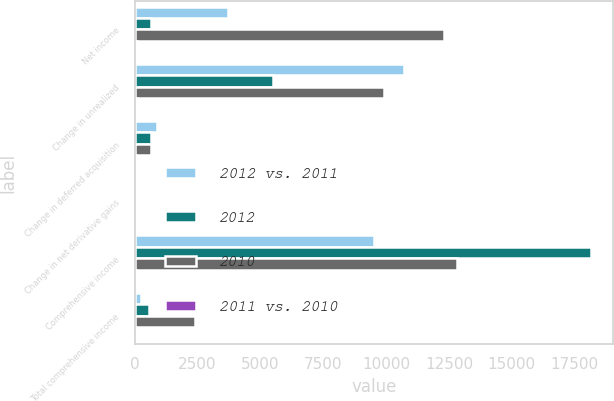Convert chart. <chart><loc_0><loc_0><loc_500><loc_500><stacked_bar_chart><ecel><fcel>Net income<fcel>Change in unrealized<fcel>Change in deferred acquisition<fcel>Change in net derivative gains<fcel>Comprehensive income<fcel>Total comprehensive income<nl><fcel>2012 vs. 2011<fcel>3700<fcel>10710<fcel>889<fcel>33<fcel>9531<fcel>265<nl><fcel>2012<fcel>657<fcel>5518<fcel>630<fcel>51<fcel>18139<fcel>587<nl><fcel>2010<fcel>12285<fcel>9910<fcel>657<fcel>105<fcel>12840<fcel>2408<nl><fcel>2011 vs. 2010<fcel>83<fcel>94<fcel>41<fcel>35<fcel>47<fcel>55<nl></chart> 